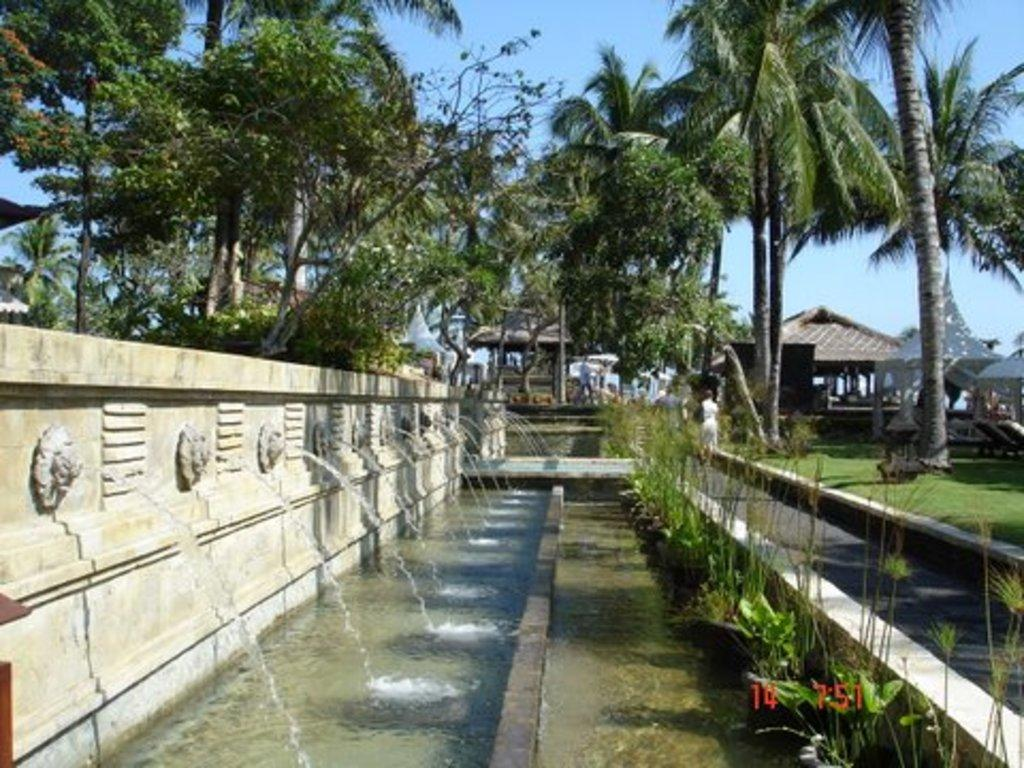What is located on the left side of the image? There is a fountain on the left side of the image. What can be seen at the bottom of the fountain? There is water and grass at the bottom of the fountain. What is visible in the background of the image? There are people, trees, sheds, and the sky visible in the background of the image. What type of tooth is being used to build the shed in the image? There is no tooth present in the image, and no construction activity involving teeth is taking place. 